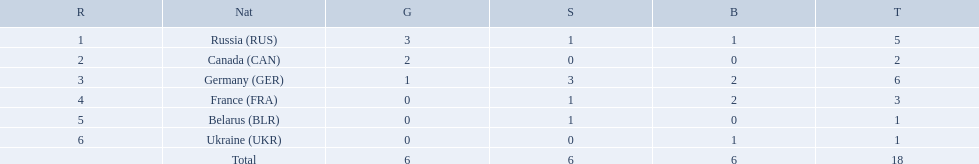Which countries received gold medals? Russia (RUS), Canada (CAN), Germany (GER). Of these countries, which did not receive a silver medal? Canada (CAN). 